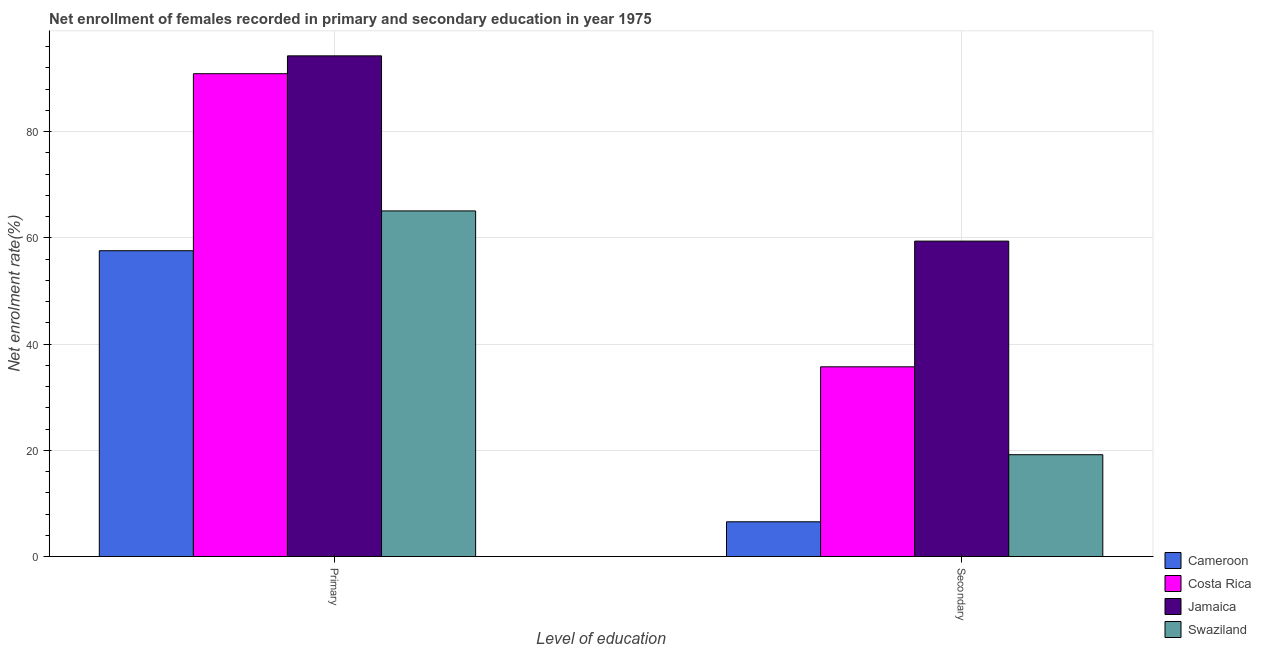How many groups of bars are there?
Provide a short and direct response. 2. Are the number of bars on each tick of the X-axis equal?
Provide a succinct answer. Yes. How many bars are there on the 2nd tick from the left?
Provide a succinct answer. 4. How many bars are there on the 2nd tick from the right?
Your answer should be compact. 4. What is the label of the 1st group of bars from the left?
Give a very brief answer. Primary. What is the enrollment rate in primary education in Jamaica?
Offer a terse response. 94.24. Across all countries, what is the maximum enrollment rate in secondary education?
Provide a succinct answer. 59.37. Across all countries, what is the minimum enrollment rate in secondary education?
Your answer should be very brief. 6.54. In which country was the enrollment rate in primary education maximum?
Make the answer very short. Jamaica. In which country was the enrollment rate in primary education minimum?
Keep it short and to the point. Cameroon. What is the total enrollment rate in secondary education in the graph?
Your response must be concise. 120.79. What is the difference between the enrollment rate in secondary education in Swaziland and that in Cameroon?
Offer a terse response. 12.63. What is the difference between the enrollment rate in primary education in Cameroon and the enrollment rate in secondary education in Jamaica?
Offer a terse response. -1.81. What is the average enrollment rate in secondary education per country?
Ensure brevity in your answer.  30.2. What is the difference between the enrollment rate in secondary education and enrollment rate in primary education in Costa Rica?
Your answer should be very brief. -55.17. What is the ratio of the enrollment rate in secondary education in Cameroon to that in Costa Rica?
Provide a short and direct response. 0.18. Is the enrollment rate in primary education in Swaziland less than that in Cameroon?
Give a very brief answer. No. What does the 1st bar from the left in Primary represents?
Offer a very short reply. Cameroon. What does the 1st bar from the right in Secondary represents?
Ensure brevity in your answer.  Swaziland. How many bars are there?
Make the answer very short. 8. What is the difference between two consecutive major ticks on the Y-axis?
Your answer should be very brief. 20. Does the graph contain any zero values?
Make the answer very short. No. How many legend labels are there?
Ensure brevity in your answer.  4. What is the title of the graph?
Your response must be concise. Net enrollment of females recorded in primary and secondary education in year 1975. What is the label or title of the X-axis?
Your response must be concise. Level of education. What is the label or title of the Y-axis?
Give a very brief answer. Net enrolment rate(%). What is the Net enrolment rate(%) of Cameroon in Primary?
Your answer should be compact. 57.57. What is the Net enrolment rate(%) in Costa Rica in Primary?
Give a very brief answer. 90.88. What is the Net enrolment rate(%) of Jamaica in Primary?
Give a very brief answer. 94.24. What is the Net enrolment rate(%) of Swaziland in Primary?
Keep it short and to the point. 65.06. What is the Net enrolment rate(%) in Cameroon in Secondary?
Your response must be concise. 6.54. What is the Net enrolment rate(%) of Costa Rica in Secondary?
Provide a short and direct response. 35.71. What is the Net enrolment rate(%) of Jamaica in Secondary?
Your answer should be very brief. 59.37. What is the Net enrolment rate(%) in Swaziland in Secondary?
Your response must be concise. 19.16. Across all Level of education, what is the maximum Net enrolment rate(%) in Cameroon?
Provide a short and direct response. 57.57. Across all Level of education, what is the maximum Net enrolment rate(%) in Costa Rica?
Give a very brief answer. 90.88. Across all Level of education, what is the maximum Net enrolment rate(%) of Jamaica?
Keep it short and to the point. 94.24. Across all Level of education, what is the maximum Net enrolment rate(%) in Swaziland?
Give a very brief answer. 65.06. Across all Level of education, what is the minimum Net enrolment rate(%) in Cameroon?
Ensure brevity in your answer.  6.54. Across all Level of education, what is the minimum Net enrolment rate(%) of Costa Rica?
Give a very brief answer. 35.71. Across all Level of education, what is the minimum Net enrolment rate(%) of Jamaica?
Your response must be concise. 59.37. Across all Level of education, what is the minimum Net enrolment rate(%) of Swaziland?
Provide a succinct answer. 19.16. What is the total Net enrolment rate(%) of Cameroon in the graph?
Provide a short and direct response. 64.1. What is the total Net enrolment rate(%) of Costa Rica in the graph?
Keep it short and to the point. 126.6. What is the total Net enrolment rate(%) of Jamaica in the graph?
Offer a very short reply. 153.62. What is the total Net enrolment rate(%) of Swaziland in the graph?
Provide a succinct answer. 84.22. What is the difference between the Net enrolment rate(%) of Cameroon in Primary and that in Secondary?
Give a very brief answer. 51.03. What is the difference between the Net enrolment rate(%) of Costa Rica in Primary and that in Secondary?
Your response must be concise. 55.17. What is the difference between the Net enrolment rate(%) in Jamaica in Primary and that in Secondary?
Your answer should be compact. 34.87. What is the difference between the Net enrolment rate(%) in Swaziland in Primary and that in Secondary?
Ensure brevity in your answer.  45.89. What is the difference between the Net enrolment rate(%) in Cameroon in Primary and the Net enrolment rate(%) in Costa Rica in Secondary?
Ensure brevity in your answer.  21.85. What is the difference between the Net enrolment rate(%) in Cameroon in Primary and the Net enrolment rate(%) in Jamaica in Secondary?
Your answer should be very brief. -1.81. What is the difference between the Net enrolment rate(%) in Cameroon in Primary and the Net enrolment rate(%) in Swaziland in Secondary?
Provide a short and direct response. 38.4. What is the difference between the Net enrolment rate(%) in Costa Rica in Primary and the Net enrolment rate(%) in Jamaica in Secondary?
Your answer should be very brief. 31.51. What is the difference between the Net enrolment rate(%) of Costa Rica in Primary and the Net enrolment rate(%) of Swaziland in Secondary?
Your response must be concise. 71.72. What is the difference between the Net enrolment rate(%) in Jamaica in Primary and the Net enrolment rate(%) in Swaziland in Secondary?
Your answer should be compact. 75.08. What is the average Net enrolment rate(%) in Cameroon per Level of education?
Your answer should be very brief. 32.05. What is the average Net enrolment rate(%) in Costa Rica per Level of education?
Give a very brief answer. 63.3. What is the average Net enrolment rate(%) of Jamaica per Level of education?
Offer a terse response. 76.81. What is the average Net enrolment rate(%) in Swaziland per Level of education?
Provide a short and direct response. 42.11. What is the difference between the Net enrolment rate(%) of Cameroon and Net enrolment rate(%) of Costa Rica in Primary?
Your response must be concise. -33.32. What is the difference between the Net enrolment rate(%) in Cameroon and Net enrolment rate(%) in Jamaica in Primary?
Your answer should be very brief. -36.68. What is the difference between the Net enrolment rate(%) in Cameroon and Net enrolment rate(%) in Swaziland in Primary?
Offer a terse response. -7.49. What is the difference between the Net enrolment rate(%) in Costa Rica and Net enrolment rate(%) in Jamaica in Primary?
Your answer should be very brief. -3.36. What is the difference between the Net enrolment rate(%) in Costa Rica and Net enrolment rate(%) in Swaziland in Primary?
Your response must be concise. 25.83. What is the difference between the Net enrolment rate(%) in Jamaica and Net enrolment rate(%) in Swaziland in Primary?
Provide a succinct answer. 29.19. What is the difference between the Net enrolment rate(%) in Cameroon and Net enrolment rate(%) in Costa Rica in Secondary?
Ensure brevity in your answer.  -29.17. What is the difference between the Net enrolment rate(%) in Cameroon and Net enrolment rate(%) in Jamaica in Secondary?
Give a very brief answer. -52.83. What is the difference between the Net enrolment rate(%) in Cameroon and Net enrolment rate(%) in Swaziland in Secondary?
Give a very brief answer. -12.63. What is the difference between the Net enrolment rate(%) of Costa Rica and Net enrolment rate(%) of Jamaica in Secondary?
Ensure brevity in your answer.  -23.66. What is the difference between the Net enrolment rate(%) of Costa Rica and Net enrolment rate(%) of Swaziland in Secondary?
Keep it short and to the point. 16.55. What is the difference between the Net enrolment rate(%) of Jamaica and Net enrolment rate(%) of Swaziland in Secondary?
Provide a short and direct response. 40.21. What is the ratio of the Net enrolment rate(%) of Cameroon in Primary to that in Secondary?
Provide a succinct answer. 8.8. What is the ratio of the Net enrolment rate(%) of Costa Rica in Primary to that in Secondary?
Your answer should be compact. 2.54. What is the ratio of the Net enrolment rate(%) in Jamaica in Primary to that in Secondary?
Ensure brevity in your answer.  1.59. What is the ratio of the Net enrolment rate(%) of Swaziland in Primary to that in Secondary?
Offer a terse response. 3.39. What is the difference between the highest and the second highest Net enrolment rate(%) of Cameroon?
Ensure brevity in your answer.  51.03. What is the difference between the highest and the second highest Net enrolment rate(%) in Costa Rica?
Give a very brief answer. 55.17. What is the difference between the highest and the second highest Net enrolment rate(%) in Jamaica?
Your answer should be compact. 34.87. What is the difference between the highest and the second highest Net enrolment rate(%) in Swaziland?
Provide a short and direct response. 45.89. What is the difference between the highest and the lowest Net enrolment rate(%) of Cameroon?
Your answer should be very brief. 51.03. What is the difference between the highest and the lowest Net enrolment rate(%) of Costa Rica?
Provide a short and direct response. 55.17. What is the difference between the highest and the lowest Net enrolment rate(%) in Jamaica?
Offer a very short reply. 34.87. What is the difference between the highest and the lowest Net enrolment rate(%) in Swaziland?
Your answer should be compact. 45.89. 